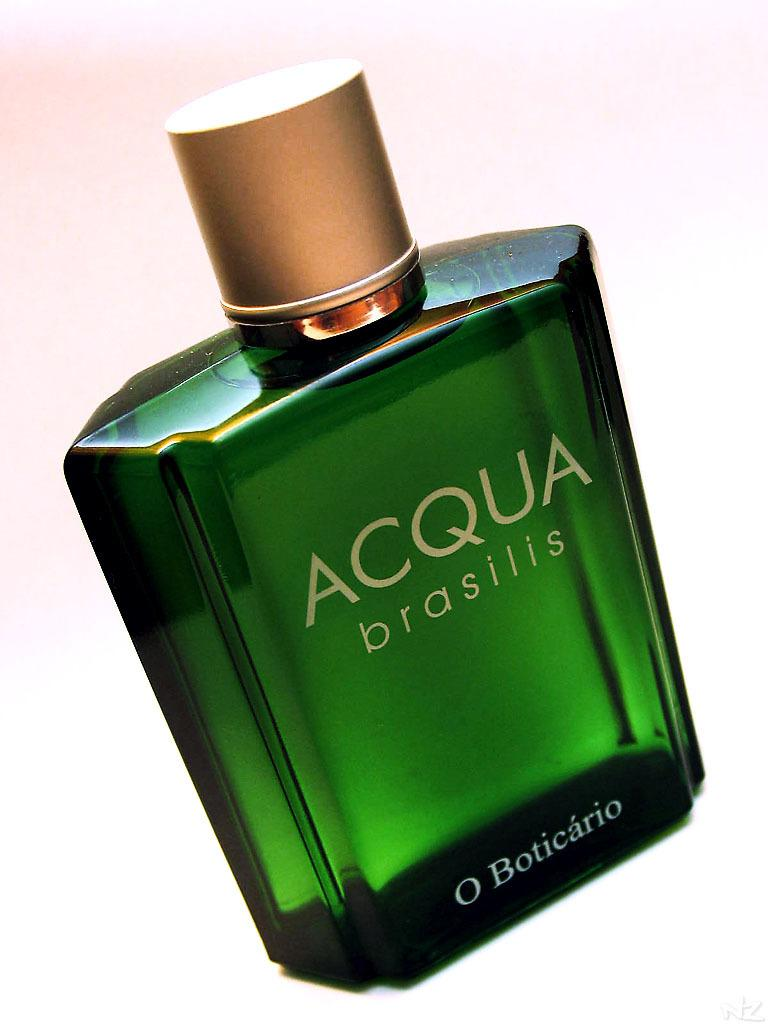<image>
Present a compact description of the photo's key features. A close up shows a green bottle of Acqua brasilis by O Boticario. 